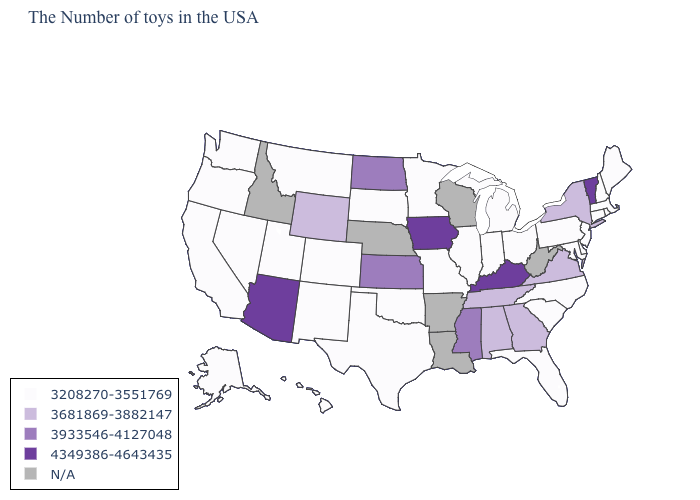Which states hav the highest value in the MidWest?
Answer briefly. Iowa. What is the value of Arizona?
Quick response, please. 4349386-4643435. Does the first symbol in the legend represent the smallest category?
Answer briefly. Yes. Name the states that have a value in the range 4349386-4643435?
Quick response, please. Vermont, Kentucky, Iowa, Arizona. Which states have the highest value in the USA?
Concise answer only. Vermont, Kentucky, Iowa, Arizona. Name the states that have a value in the range 3933546-4127048?
Give a very brief answer. Mississippi, Kansas, North Dakota. Name the states that have a value in the range N/A?
Give a very brief answer. West Virginia, Wisconsin, Louisiana, Arkansas, Nebraska, Idaho. What is the value of New Hampshire?
Give a very brief answer. 3208270-3551769. What is the value of Maryland?
Give a very brief answer. 3208270-3551769. Does Iowa have the highest value in the MidWest?
Write a very short answer. Yes. Does the map have missing data?
Keep it brief. Yes. What is the value of Washington?
Keep it brief. 3208270-3551769. Which states have the lowest value in the USA?
Quick response, please. Maine, Massachusetts, Rhode Island, New Hampshire, Connecticut, New Jersey, Delaware, Maryland, Pennsylvania, North Carolina, South Carolina, Ohio, Florida, Michigan, Indiana, Illinois, Missouri, Minnesota, Oklahoma, Texas, South Dakota, Colorado, New Mexico, Utah, Montana, Nevada, California, Washington, Oregon, Alaska, Hawaii. What is the value of Tennessee?
Answer briefly. 3681869-3882147. 